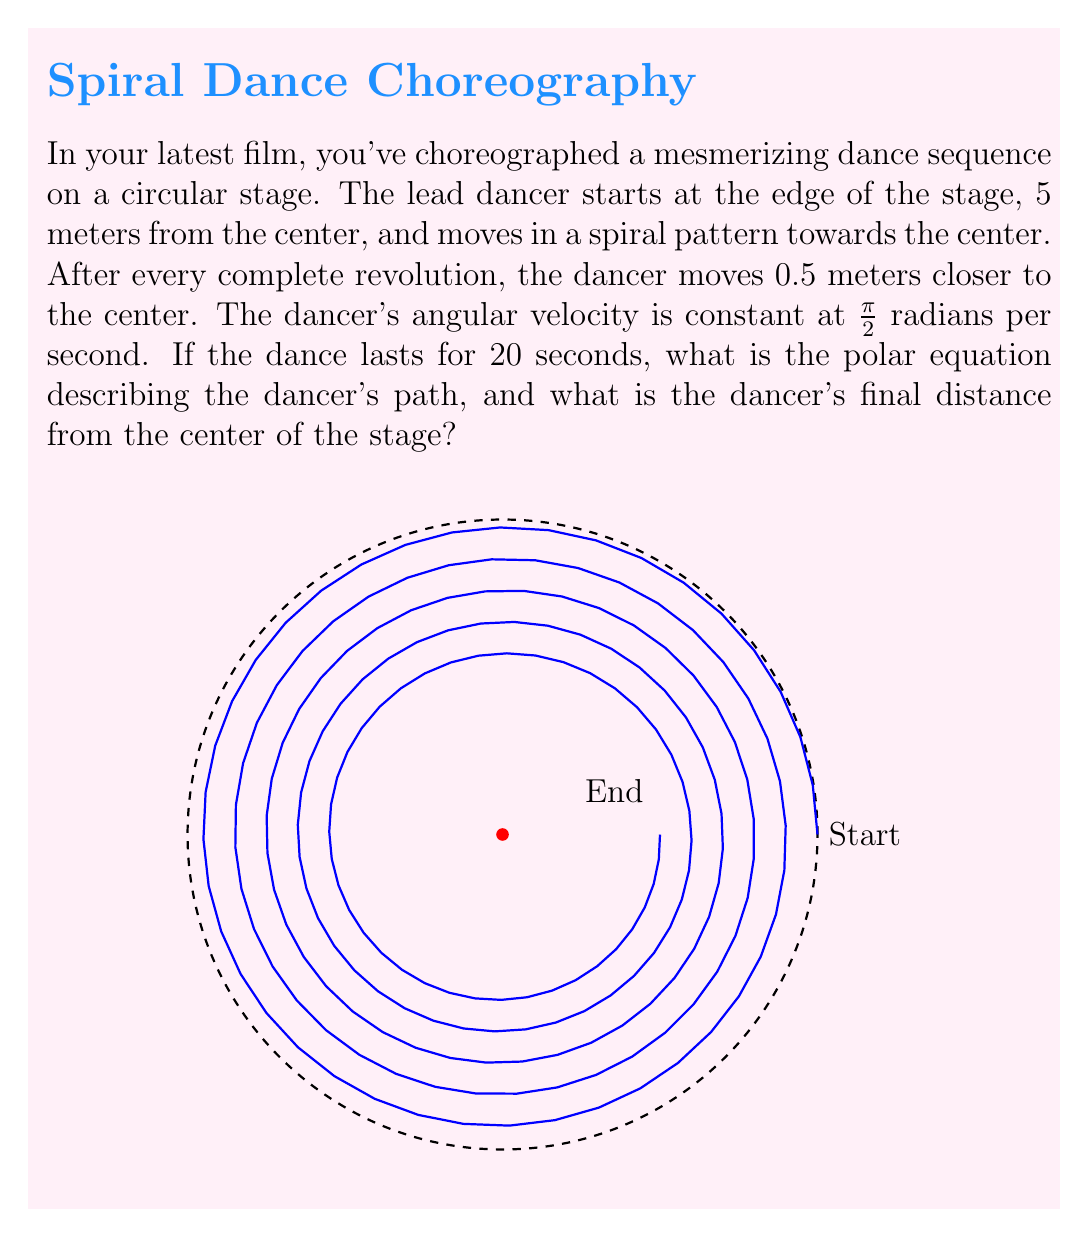Give your solution to this math problem. Let's approach this step-by-step:

1) First, we need to determine the polar equation of the spiral. The general form of a spiral in polar coordinates is:

   $$ r = a - b\theta $$

   where $a$ is the initial radius and $b$ is the rate of decrease per radian.

2) We know the initial radius is 5 meters, so $a = 5$.

3) To find $b$, we need to determine how much the radius decreases per radian:
   - The radius decreases by 0.5 meters per revolution
   - One revolution is $2\pi$ radians
   - So, $b = 0.5 / (2\pi) = 1/(4\pi)$

4) Therefore, the polar equation of the spiral is:

   $$ r = 5 - \frac{\theta}{4\pi} $$

5) Now, to find the dancer's final position, we need to determine $\theta$ after 20 seconds:
   - Angular velocity is $\pi/2$ radians per second
   - Time is 20 seconds
   - So, $\theta = (\pi/2) * 20 = 10\pi$ radians

6) Substituting this into our equation:

   $$ r = 5 - \frac{10\pi}{4\pi} = 5 - \frac{5}{2} = \frac{5}{2} = 1.25 $$

Therefore, the dancer's final distance from the center is 1.25 meters.
Answer: Polar equation: $r = 5 - \frac{\theta}{4\pi}$; Final distance: 1.25 meters 